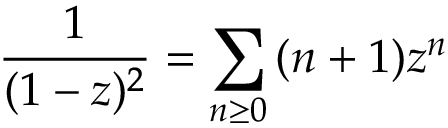Convert formula to latex. <formula><loc_0><loc_0><loc_500><loc_500>{ \frac { 1 } { ( 1 - z ) ^ { 2 } } } = \sum _ { n \geq 0 } { ( n + 1 ) z ^ { n } }</formula> 